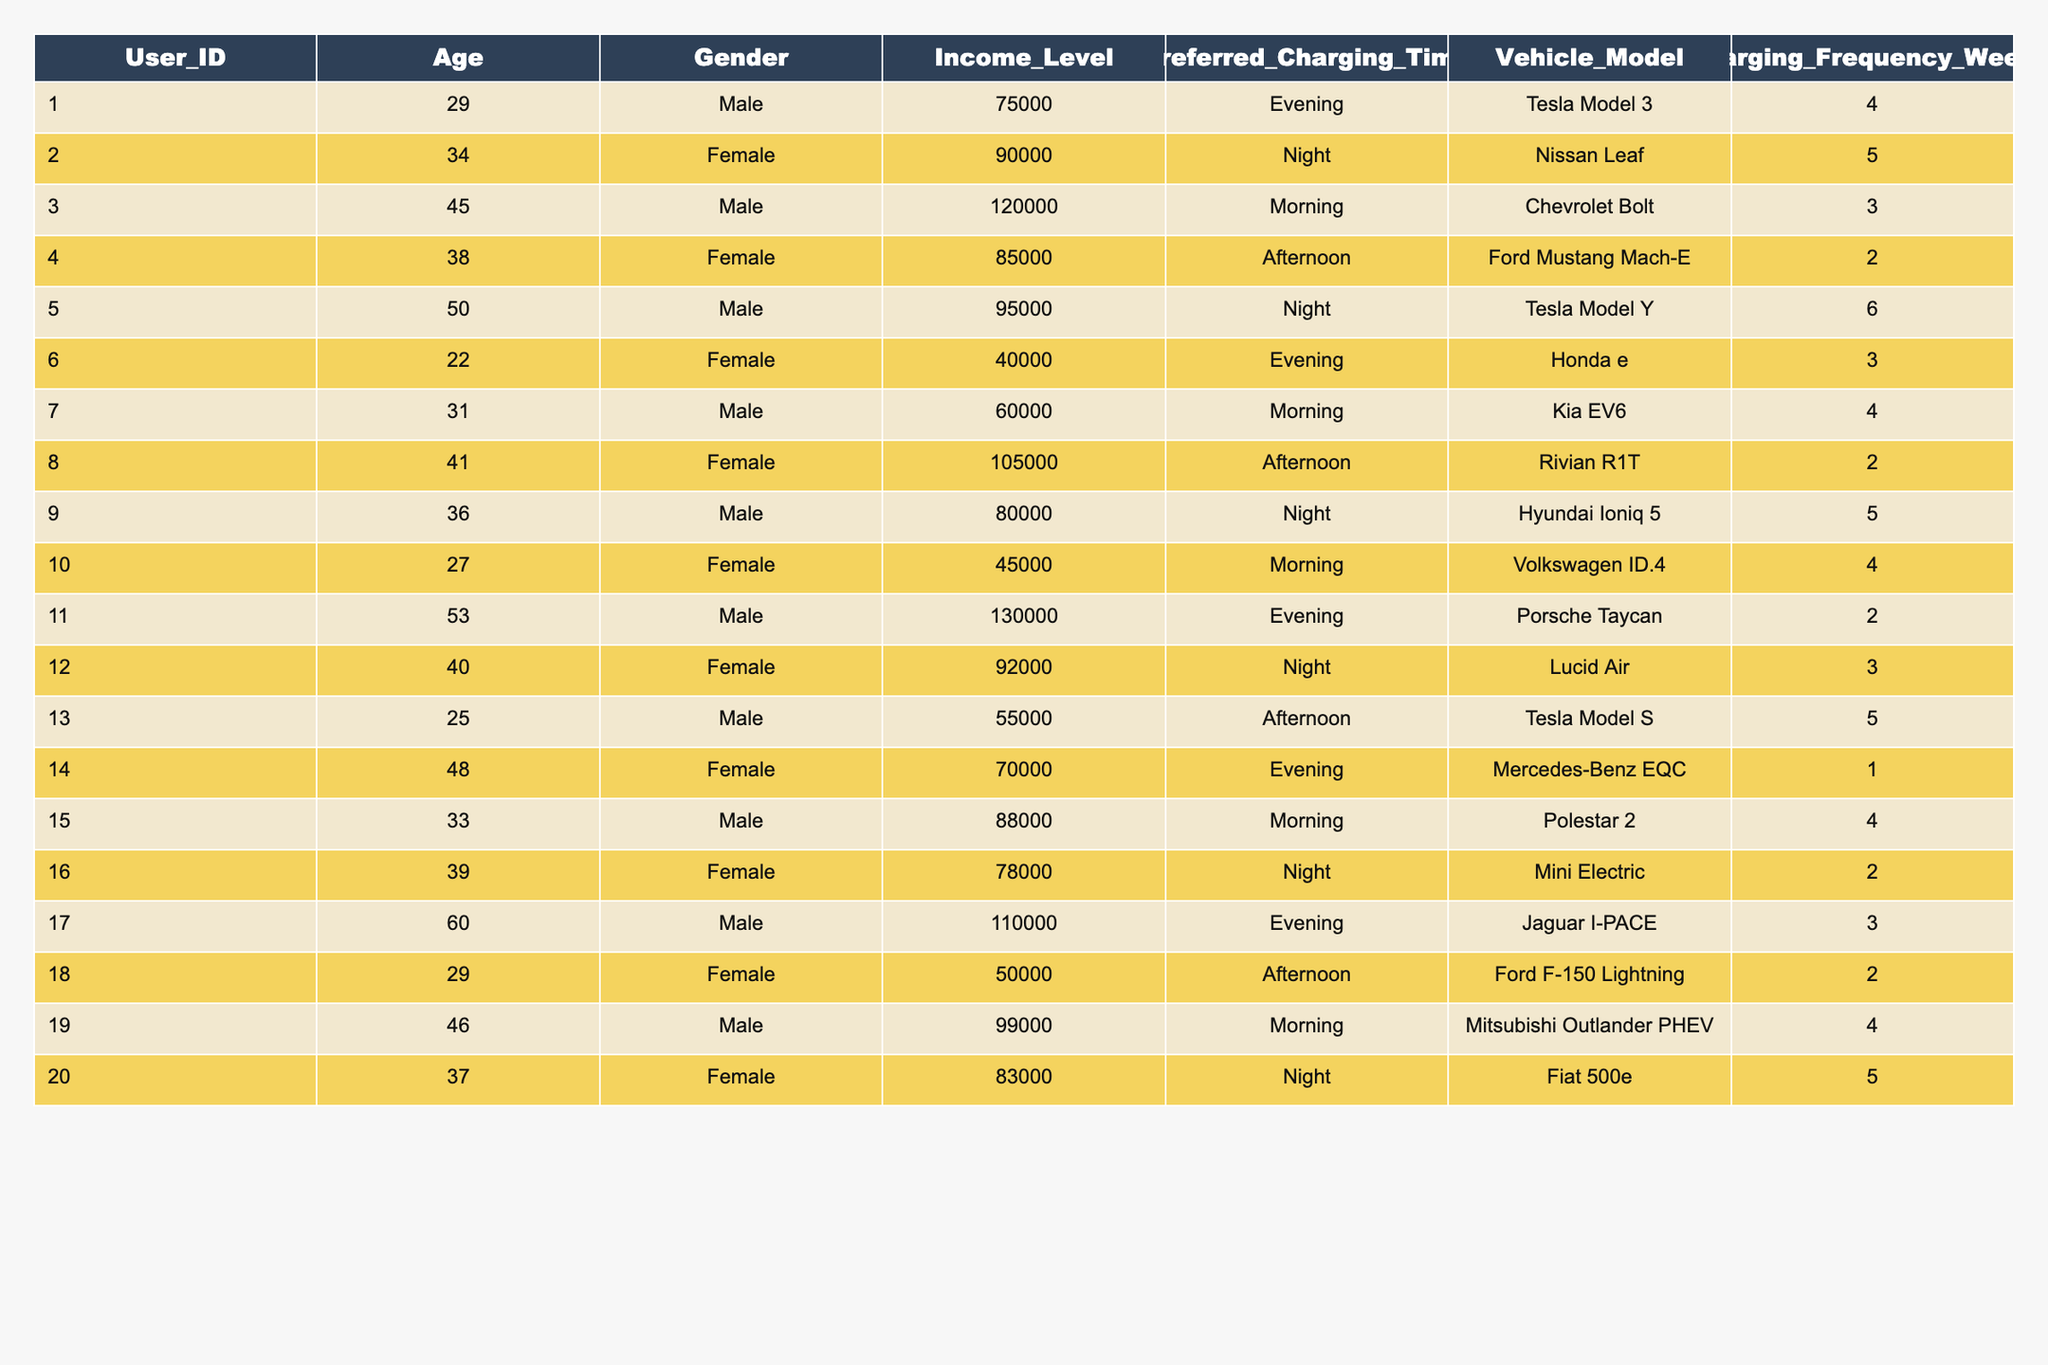What is the preferred charging time for User_ID 5? By looking at the table, the Preferred Charging Time for User_ID 5 is listed as "Night."
Answer: Night How many users prefer to charge their vehicles in the morning? The table shows that Users 3, 7, 10, 15, and 19 have their preferred charging time as "Morning." Therefore, there are 5 users.
Answer: 5 What is the total charging frequency of users who prefer charging in the evening? The charging frequencies for users preferring evening are 4 (User 1), 3 (User 11), 2 (User 14), and 3 (User 17). Adding these, we have 4 + 3 + 2 + 3 = 12.
Answer: 12 Is there any user with an income level below $50,000 in the table? Upon examining the Income_Level column, it is apparent that the lowest income is $40,000 (User 6). Thus, there is a user below $50,000.
Answer: Yes What is the difference in preferred charging frequency between males and females? Total charging frequency for males: 4 + 3 + 3 + 6 + 4 + 2 + 3 + 4 + 4 + 2 + 4 = 43. Total for females: 5 + 2 + 3 + 1 + 2 + 5 = 18. The difference is 43 - 18 = 25.
Answer: 25 Which gender has a higher average income level among users who prefer charging at night? For users preferring night charging, males (Users 2, 5, 9, 12, 16, 20) have income levels of 90,000, 95,000, 80,000, 92,000, 78,000, and 83,000 respectively = $84,500 average. Females (Users 2, 5, 12, 16, 20) have incomes of 90,000, 95,000, 92,000, 78,000, 83,000 = $86,600 average; hence, females have a higher average income level.
Answer: Females How many users prefer "Afternoon" charging and are under the age of 40? Users who prefer "Afternoon" charging are Users 4 (38) and 8 (41). Out of these, only User 4 is under 40.
Answer: 1 What is the average age of users who own a Tesla Model? The users who own Tesla Models are Users 1 (29), 5 (50), 13 (25), and 19 (46). Their ages add up to 29 + 50 + 25 + 46 = 150, and there are 4 such users; therefore, the average age is 150 / 4 = 37.5.
Answer: 37.5 Who has the highest charging frequency among female users and how many times do they charge? Analyzing the Charging Frequency for females, User 2 charges 5 times. Comparing the others (2, 3, 1, 2, 5), User 2 has the highest frequency of 5.
Answer: User 2, 5 times Is there a user aged 60 or above who prefers to charge in the evening? There is one user at the age of 60 who prefers to charge in the evening (User 17).
Answer: Yes 